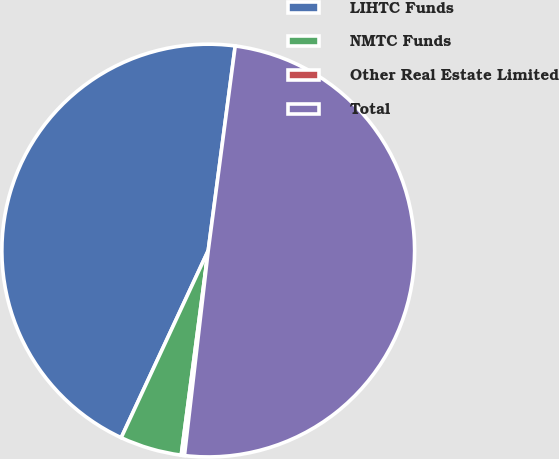<chart> <loc_0><loc_0><loc_500><loc_500><pie_chart><fcel>LIHTC Funds<fcel>NMTC Funds<fcel>Other Real Estate Limited<fcel>Total<nl><fcel>45.16%<fcel>4.84%<fcel>0.25%<fcel>49.75%<nl></chart> 